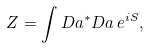<formula> <loc_0><loc_0><loc_500><loc_500>Z = \int D a ^ { * } D a \, e ^ { i S } ,</formula> 